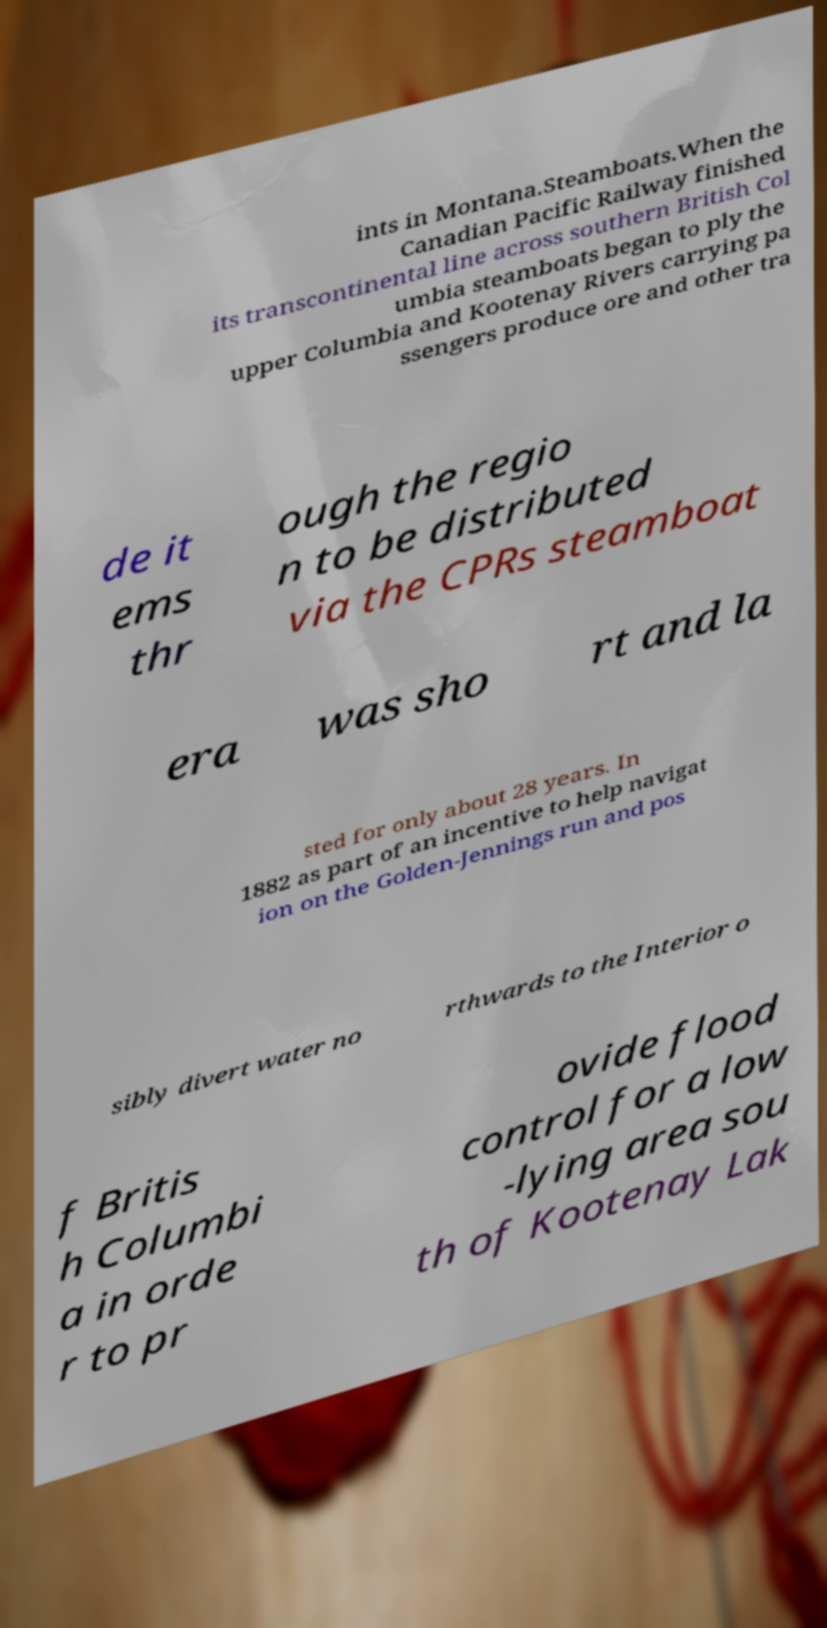What messages or text are displayed in this image? I need them in a readable, typed format. ints in Montana.Steamboats.When the Canadian Pacific Railway finished its transcontinental line across southern British Col umbia steamboats began to ply the upper Columbia and Kootenay Rivers carrying pa ssengers produce ore and other tra de it ems thr ough the regio n to be distributed via the CPRs steamboat era was sho rt and la sted for only about 28 years. In 1882 as part of an incentive to help navigat ion on the Golden-Jennings run and pos sibly divert water no rthwards to the Interior o f Britis h Columbi a in orde r to pr ovide flood control for a low -lying area sou th of Kootenay Lak 